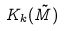Convert formula to latex. <formula><loc_0><loc_0><loc_500><loc_500>K _ { k } ( \tilde { M } )</formula> 